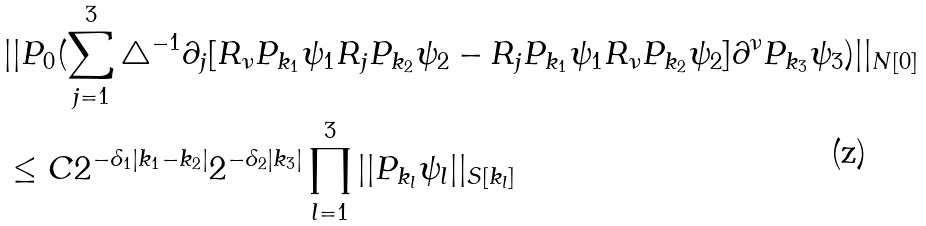Convert formula to latex. <formula><loc_0><loc_0><loc_500><loc_500>& | | P _ { 0 } ( \sum _ { j = 1 } ^ { 3 } \triangle ^ { - 1 } \partial _ { j } [ R _ { \nu } P _ { k _ { 1 } } \psi _ { 1 } R _ { j } P _ { k _ { 2 } } \psi _ { 2 } - R _ { j } P _ { k _ { 1 } } \psi _ { 1 } R _ { \nu } P _ { k _ { 2 } } \psi _ { 2 } ] \partial ^ { \nu } P _ { k _ { 3 } } \psi _ { 3 } ) | | _ { N [ 0 ] } \\ & \leq C 2 ^ { - \delta _ { 1 } | k _ { 1 } - k _ { 2 } | } 2 ^ { - \delta _ { 2 } | k _ { 3 } | } \prod _ { l = 1 } ^ { 3 } | | P _ { k _ { l } } \psi _ { l } | | _ { S [ k _ { l } ] } \\</formula> 